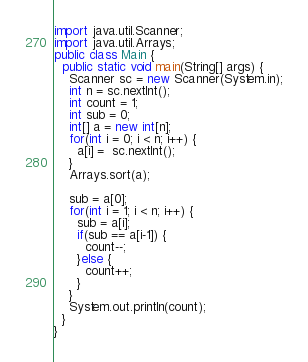<code> <loc_0><loc_0><loc_500><loc_500><_Java_>import java.util.Scanner;
import java.util.Arrays;
public class Main {
  public static void main(String[] args) {
    Scanner sc = new Scanner(System.in);
    int n = sc.nextInt();
    int count = 1;
    int sub = 0;
    int[] a = new int[n];
    for(int i = 0; i < n; i++) {
      a[i] =  sc.nextInt();
    }
    Arrays.sort(a);

    sub = a[0];
    for(int i = 1; i < n; i++) {
      sub = a[i];
      if(sub == a[i-1]) {
        count--;
      }else {
        count++;
      }
    }
    System.out.println(count);
  }
}
</code> 